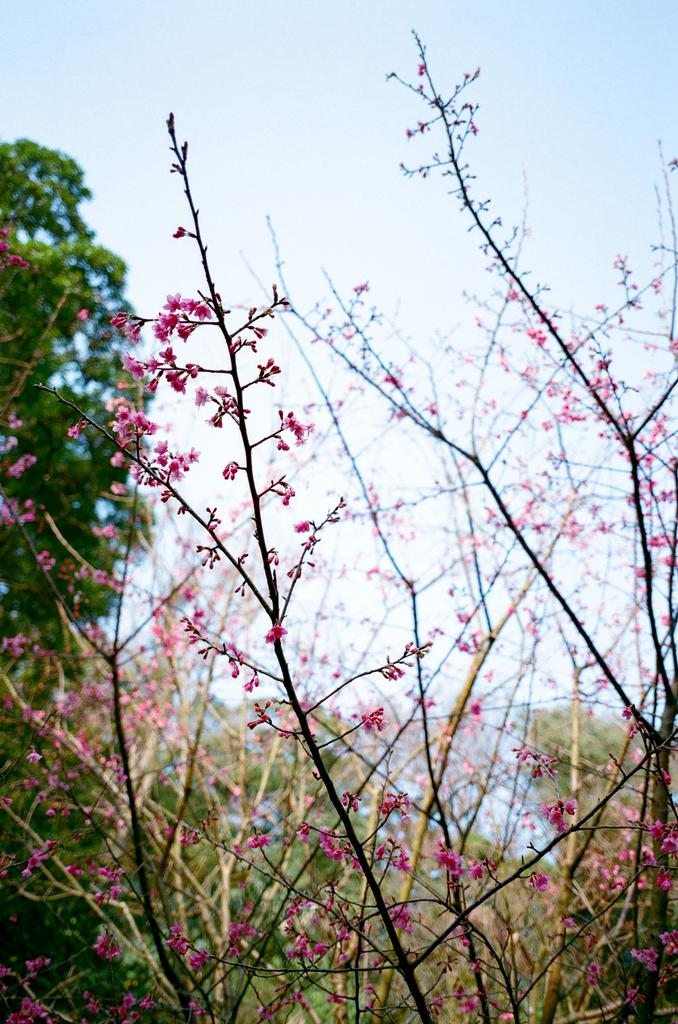What is present on the dry branches of the plant in the image? There are flowers on the dry branches of a plant in the image. What can be seen in the background behind the plant? There are trees visible behind the plant in the image. What type of poison is being used to water the plant in the image? There is no indication in the image that any poison is being used to water the plant. What rule is being enforced by the presence of the plant in the image? There is no rule being enforced by the presence of the plant in the image. 